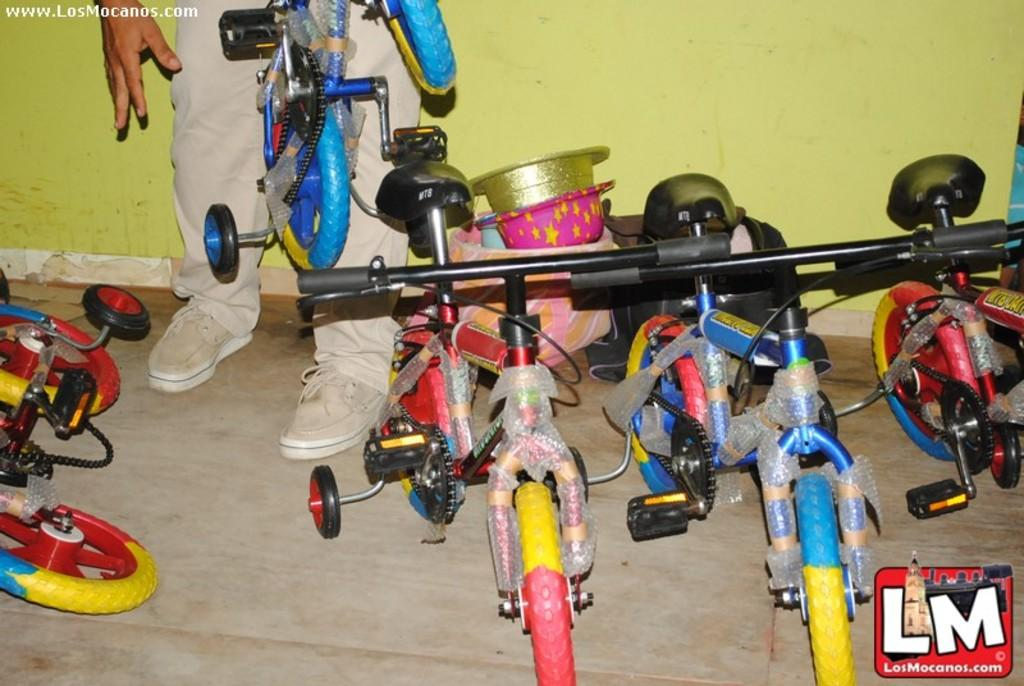What type of vehicles are in the image? There are bicycles in the image. What type of clothing accessories are in the image? There are hats in the image. Can you describe the person in the image? There is a person in the image. What is the background of the image? There is a wall in the image. What type of pest can be seen crawling on the wall in the image? There is no pest visible on the wall in the image. What is the person using to carry water in the image? There is no pail or any indication of carrying water present in the image. 